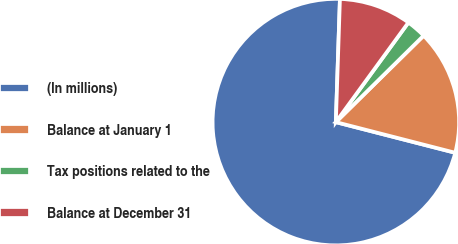<chart> <loc_0><loc_0><loc_500><loc_500><pie_chart><fcel>(In millions)<fcel>Balance at January 1<fcel>Tax positions related to the<fcel>Balance at December 31<nl><fcel>71.53%<fcel>16.38%<fcel>2.6%<fcel>9.49%<nl></chart> 